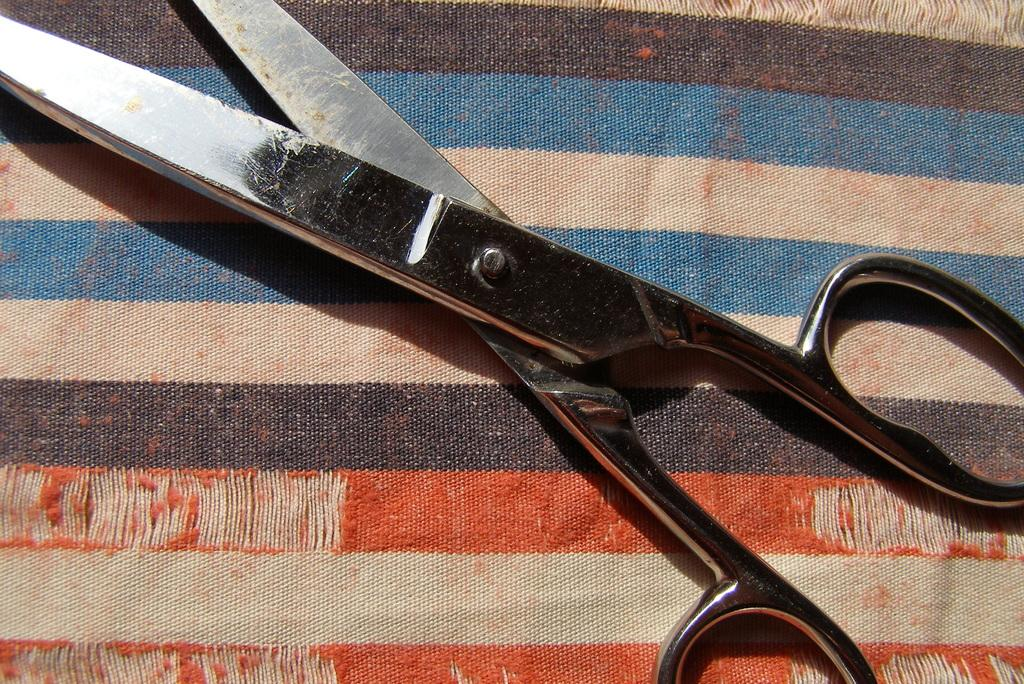What is the main feature of the image? There is a colorful cloth in the image. What object is placed on the cloth? There is an iron scissor on the cloth. What type of soup is being prepared by the girls near the gate in the image? There are no girls or gates present in the image, and no soup is being prepared. 